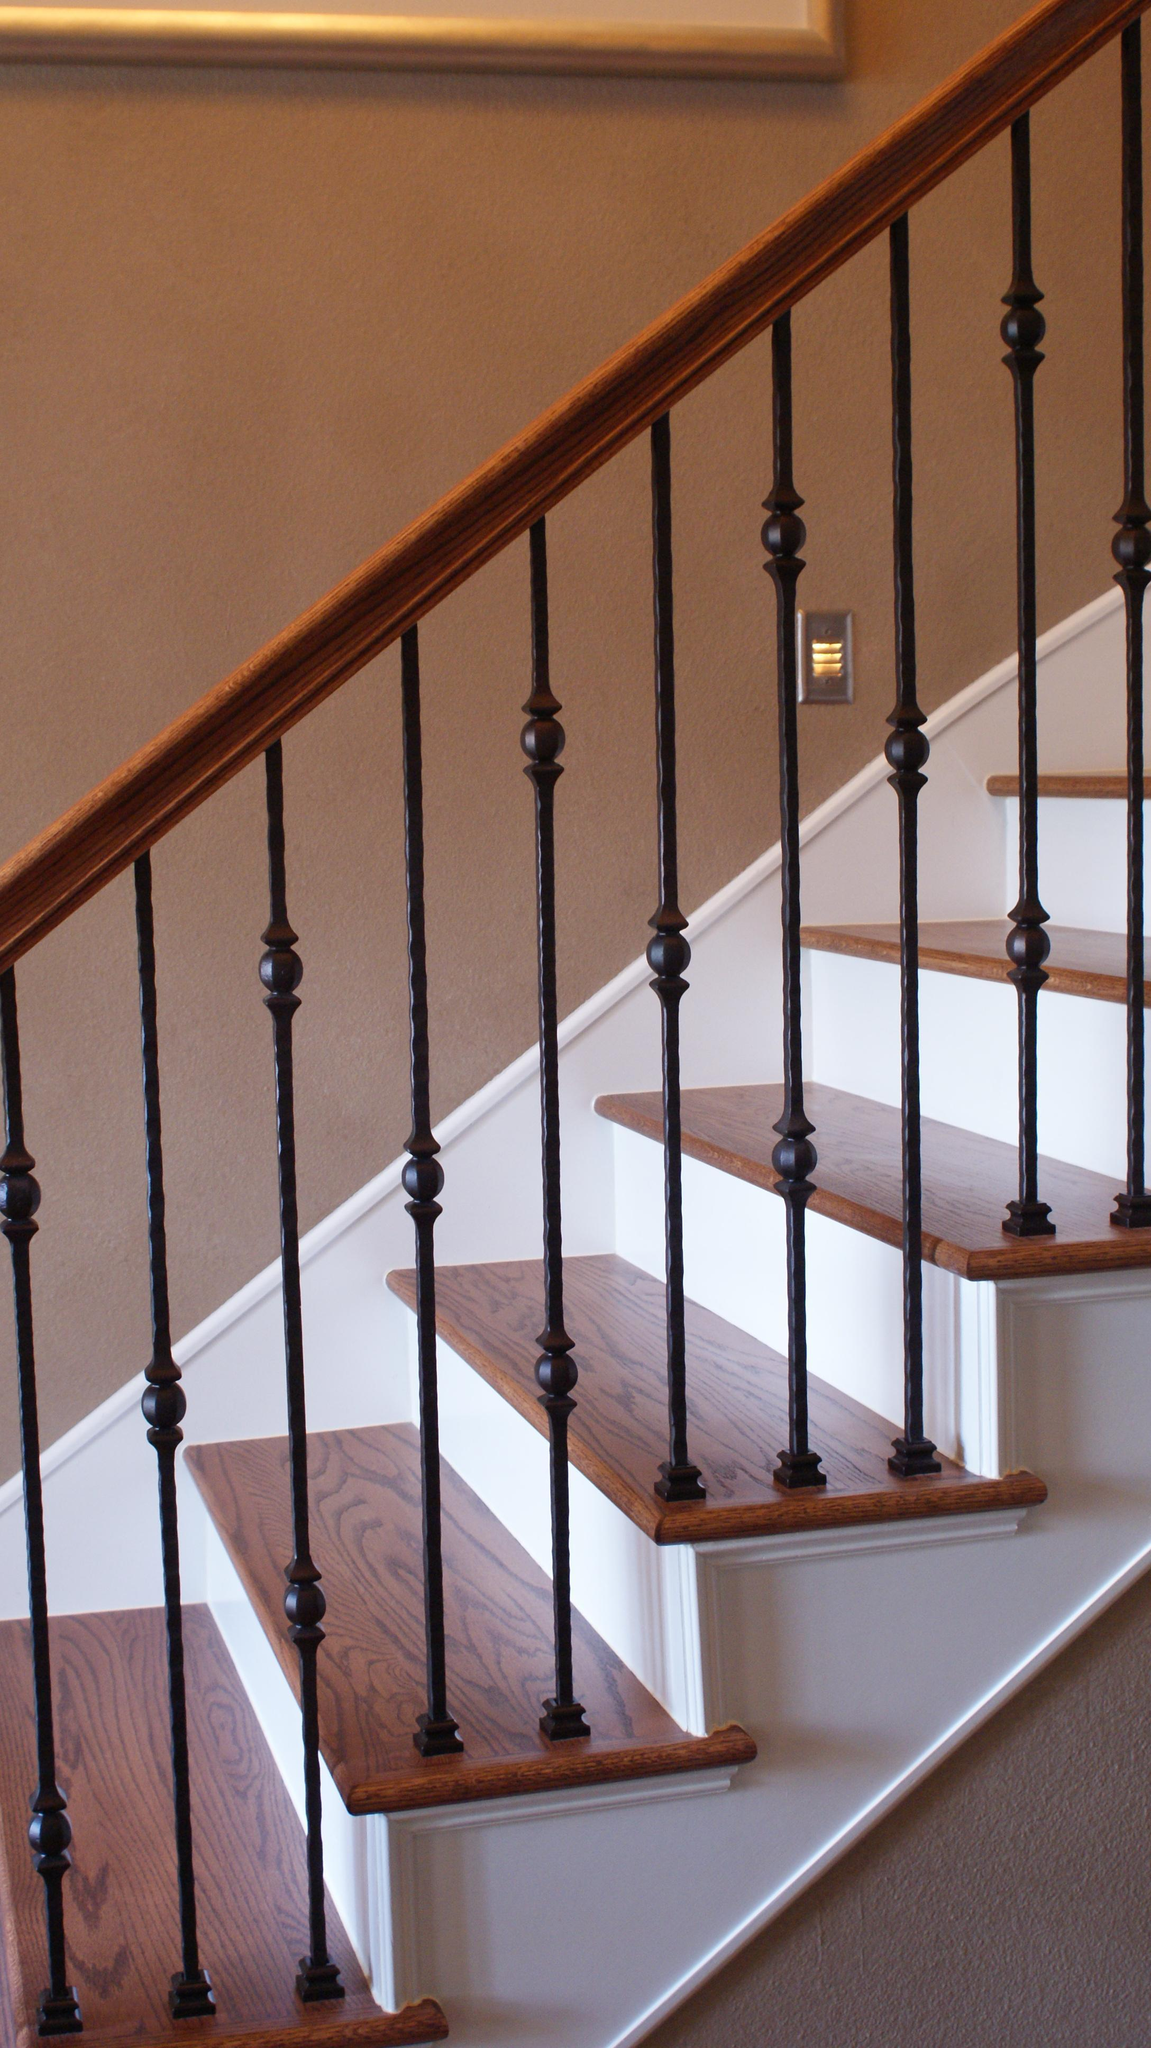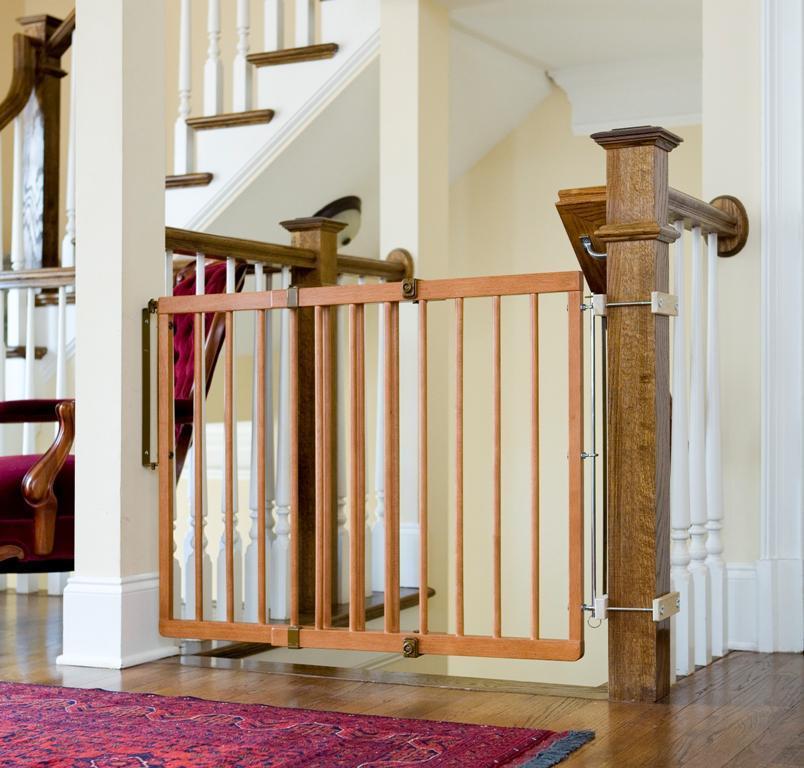The first image is the image on the left, the second image is the image on the right. For the images displayed, is the sentence "The right image shows a gate with vertical bars mounted to posts on each side to protect from falls, and a set of stairs is visible in the image." factually correct? Answer yes or no. Yes. The first image is the image on the left, the second image is the image on the right. For the images shown, is this caption "A staircase has wooden handles with black bars." true? Answer yes or no. Yes. 